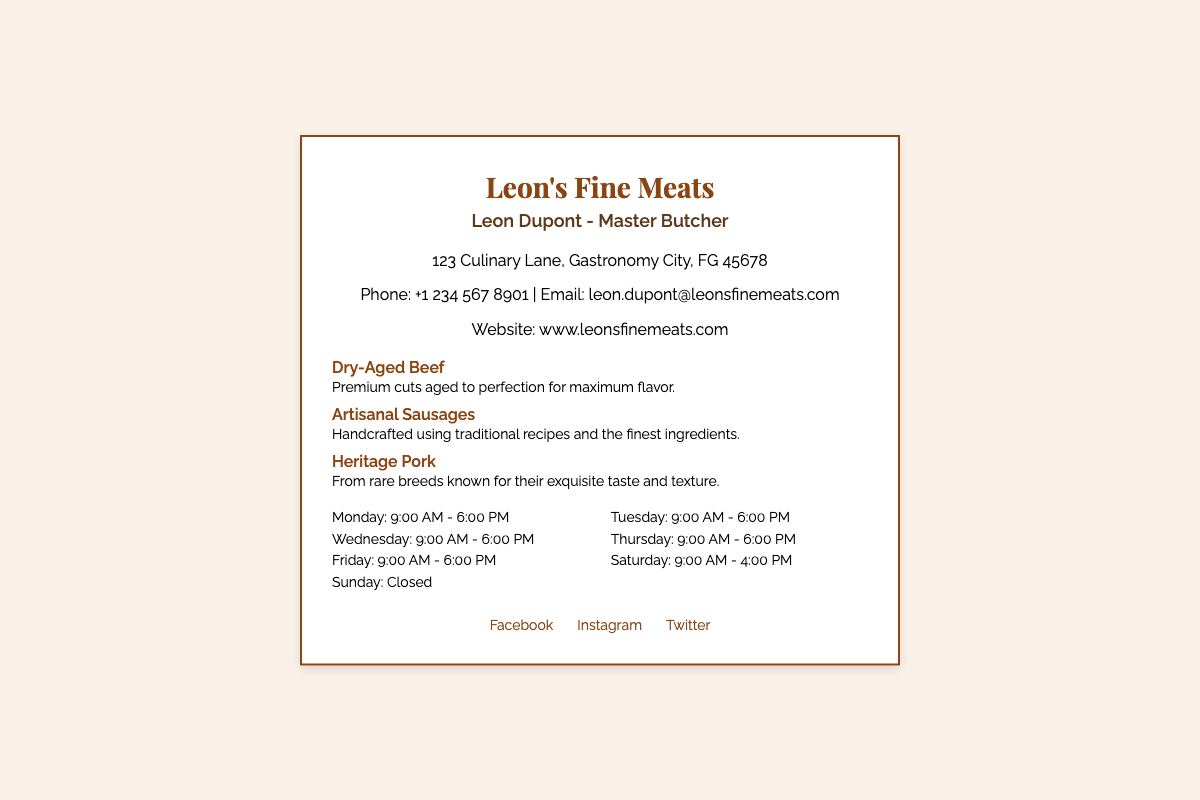What is the name of the butcher? The name of the butcher is prominently displayed as "Leon Dupont".
Answer: Leon Dupont What is the address of Leon's Fine Meats? The address is listed in the contact information section.
Answer: 123 Culinary Lane, Gastronomy City, FG 45678 What is Leon Dupont's phone number? The phone number is provided in the contact information.
Answer: +1 234 567 8901 What are the business hours on Saturday? The business hours on Saturday are specified in the hours section.
Answer: 9:00 AM - 4:00 PM Which specialty is described as aged to perfection? The specialty that is aged to perfection is indicated in the specialties section.
Answer: Dry-Aged Beef What type of pork is highlighted in the specialties? The type of pork mentioned is detailed in the specialties section.
Answer: Heritage Pork What social media platforms are mentioned? The social media platforms are listed in the social media section of the card.
Answer: Facebook, Instagram, Twitter How many days a week is Leon's Fine Meats open? The operational days of the business are specified in the document.
Answer: Six days What is the main title of Leon Dupont? The main title is mentioned directly under the name.
Answer: Master Butcher 